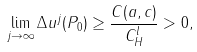Convert formula to latex. <formula><loc_0><loc_0><loc_500><loc_500>\lim _ { j \rightarrow \infty } \Delta u ^ { j } ( P _ { 0 } ) \geq \frac { C ( a , c ) } { C _ { H } ^ { l } } > 0 ,</formula> 